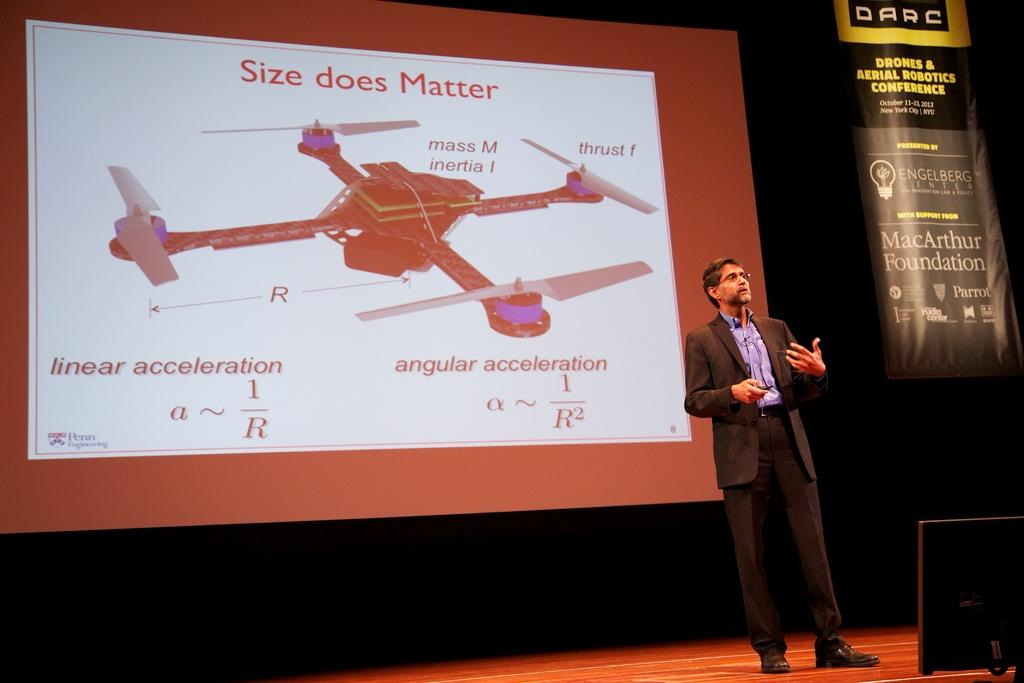<image>
Offer a succinct explanation of the picture presented. A man speaking on a stage with a picture of a drone and the words size does matter behind him on a projection screen. 